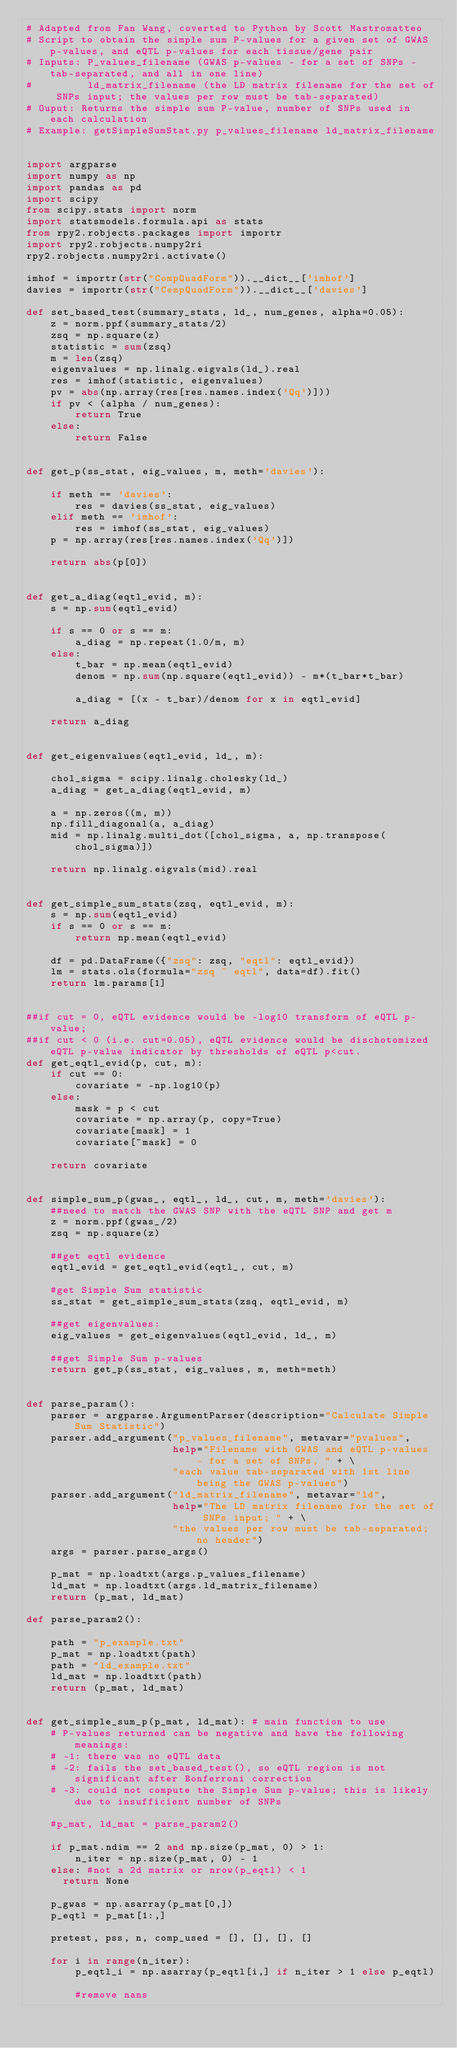Convert code to text. <code><loc_0><loc_0><loc_500><loc_500><_Python_># Adapted from Fan Wang, coverted to Python by Scott Mastromatteo
# Script to obtain the simple sum P-values for a given set of GWAS p-values, and eQTL p-values for each tissue/gene pair
# Inputs: P_values_filename (GWAS p-values - for a set of SNPs - tab-separated, and all in one line)
#         ld_matrix_filename (the LD matrix filename for the set of SNPs input; the values per row must be tab-separated)
# Ouput: Returns the simple sum P-value, number of SNPs used in each calculation
# Example: getSimpleSumStat.py p_values_filename ld_matrix_filename


import argparse
import numpy as np
import pandas as pd
import scipy
from scipy.stats import norm
import statsmodels.formula.api as stats
from rpy2.robjects.packages import importr
import rpy2.robjects.numpy2ri
rpy2.robjects.numpy2ri.activate()

imhof = importr(str("CompQuadForm")).__dict__['imhof']
davies = importr(str("CompQuadForm")).__dict__['davies']

def set_based_test(summary_stats, ld_, num_genes, alpha=0.05):
    z = norm.ppf(summary_stats/2)
    zsq = np.square(z)
    statistic = sum(zsq)
    m = len(zsq)
    eigenvalues = np.linalg.eigvals(ld_).real
    res = imhof(statistic, eigenvalues)
    pv = abs(np.array(res[res.names.index('Qq')]))
    if pv < (alpha / num_genes):
        return True
    else:
        return False


def get_p(ss_stat, eig_values, m, meth='davies'):

    if meth == 'davies':
        res = davies(ss_stat, eig_values)
    elif meth == 'imhof':
        res = imhof(ss_stat, eig_values)
    p = np.array(res[res.names.index('Qq')])

    return abs(p[0])

  
def get_a_diag(eqtl_evid, m):
    s = np.sum(eqtl_evid)

    if s == 0 or s == m:
        a_diag = np.repeat(1.0/m, m)
    else:
        t_bar = np.mean(eqtl_evid)
        denom = np.sum(np.square(eqtl_evid)) - m*(t_bar*t_bar)
      
        a_diag = [(x - t_bar)/denom for x in eqtl_evid]
      
    return a_diag


def get_eigenvalues(eqtl_evid, ld_, m):
        
    chol_sigma = scipy.linalg.cholesky(ld_)
    a_diag = get_a_diag(eqtl_evid, m)
    
    a = np.zeros((m, m)) 
    np.fill_diagonal(a, a_diag)
    mid = np.linalg.multi_dot([chol_sigma, a, np.transpose(chol_sigma)])
    
    return np.linalg.eigvals(mid).real


def get_simple_sum_stats(zsq, eqtl_evid, m):
    s = np.sum(eqtl_evid)
    if s == 0 or s == m:
        return np.mean(eqtl_evid)
    
    df = pd.DataFrame({"zsq": zsq, "eqtl": eqtl_evid})
    lm = stats.ols(formula="zsq ~ eqtl", data=df).fit()
    return lm.params[1]


##if cut = 0, eQTL evidence would be -log10 transform of eQTL p-value;
##if cut < 0 (i.e. cut=0.05), eQTL evidence would be dischotomized eQTL p-value indicator by thresholds of eQTL p<cut.
def get_eqtl_evid(p, cut, m):
    if cut == 0:
        covariate = -np.log10(p)
    else:
        mask = p < cut
        covariate = np.array(p, copy=True) 
        covariate[mask] = 1
        covariate[~mask] = 0
    
    return covariate


def simple_sum_p(gwas_, eqtl_, ld_, cut, m, meth='davies'):
    ##need to match the GWAS SNP with the eQTL SNP and get m
    z = norm.ppf(gwas_/2)
    zsq = np.square(z)

    ##get eqtl evidence
    eqtl_evid = get_eqtl_evid(eqtl_, cut, m)
    
    #get Simple Sum statistic
    ss_stat = get_simple_sum_stats(zsq, eqtl_evid, m)
    
    ##get eigenvalues:
    eig_values = get_eigenvalues(eqtl_evid, ld_, m)
    
    ##get Simple Sum p-values
    return get_p(ss_stat, eig_values, m, meth=meth)


def parse_param():
    parser = argparse.ArgumentParser(description="Calculate Simple Sum Statistic")
    parser.add_argument("p_values_filename", metavar="pvalues", 
                        help="Filename with GWAS and eQTL p-values - for a set of SNPs, " + \
                        "each value tab-separated with 1st line being the GWAS p-values")
    parser.add_argument("ld_matrix_filename", metavar="ld",
                        help="The LD matrix filename for the set of SNPs input; " + \
                        "the values per row must be tab-separated; no header")
    args = parser.parse_args()
        
    p_mat = np.loadtxt(args.p_values_filename)
    ld_mat = np.loadtxt(args.ld_matrix_filename)
    return (p_mat, ld_mat)

def parse_param2():

    path = "p_example.txt" 
    p_mat = np.loadtxt(path)
    path = "ld_example.txt" 
    ld_mat = np.loadtxt(path)
    return (p_mat, ld_mat)


def get_simple_sum_p(p_mat, ld_mat): # main function to use
    # P-values returned can be negative and have the following meanings:
    # -1: there was no eQTL data
    # -2: fails the set_based_test(), so eQTL region is not significant after Bonferroni correction
    # -3: could not compute the Simple Sum p-value; this is likely due to insufficient number of SNPs
    
    #p_mat, ld_mat = parse_param2()
    
    if p_mat.ndim == 2 and np.size(p_mat, 0) > 1:
        n_iter = np.size(p_mat, 0) - 1
    else: #not a 2d matrix or nrow(p_eqtl) < 1 
      return None
    
    p_gwas = np.asarray(p_mat[0,])
    p_eqtl = p_mat[1:,]
   
    pretest, pss, n, comp_used = [], [], [], []
    
    for i in range(n_iter):  
        p_eqtl_i = np.asarray(p_eqtl[i,] if n_iter > 1 else p_eqtl)
        
        #remove nans        </code> 